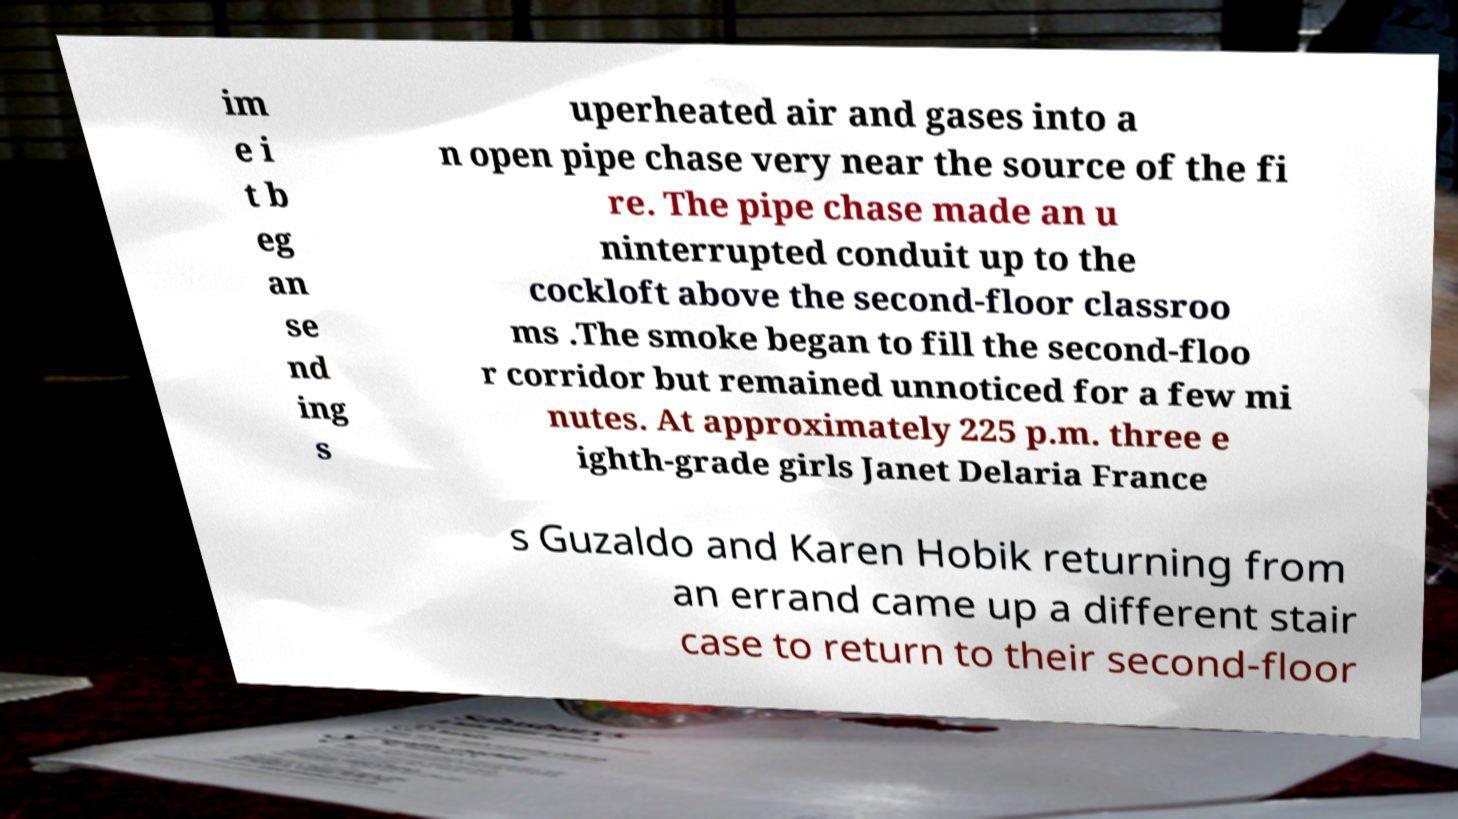For documentation purposes, I need the text within this image transcribed. Could you provide that? im e i t b eg an se nd ing s uperheated air and gases into a n open pipe chase very near the source of the fi re. The pipe chase made an u ninterrupted conduit up to the cockloft above the second-floor classroo ms .The smoke began to fill the second-floo r corridor but remained unnoticed for a few mi nutes. At approximately 225 p.m. three e ighth-grade girls Janet Delaria France s Guzaldo and Karen Hobik returning from an errand came up a different stair case to return to their second-floor 